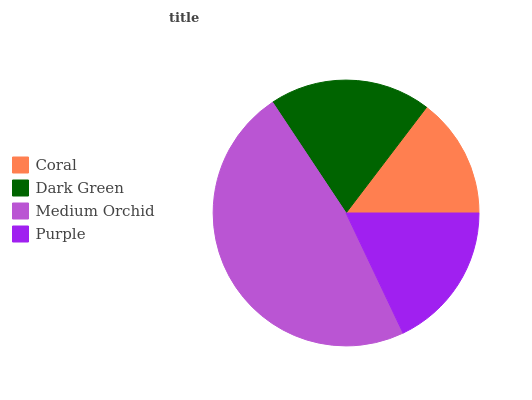Is Coral the minimum?
Answer yes or no. Yes. Is Medium Orchid the maximum?
Answer yes or no. Yes. Is Dark Green the minimum?
Answer yes or no. No. Is Dark Green the maximum?
Answer yes or no. No. Is Dark Green greater than Coral?
Answer yes or no. Yes. Is Coral less than Dark Green?
Answer yes or no. Yes. Is Coral greater than Dark Green?
Answer yes or no. No. Is Dark Green less than Coral?
Answer yes or no. No. Is Dark Green the high median?
Answer yes or no. Yes. Is Purple the low median?
Answer yes or no. Yes. Is Coral the high median?
Answer yes or no. No. Is Medium Orchid the low median?
Answer yes or no. No. 